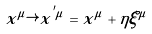<formula> <loc_0><loc_0><loc_500><loc_500>x ^ { \mu } \rightarrow x ^ { ^ { \prime } \mu } = x ^ { \mu } + \eta \xi ^ { \mu }</formula> 